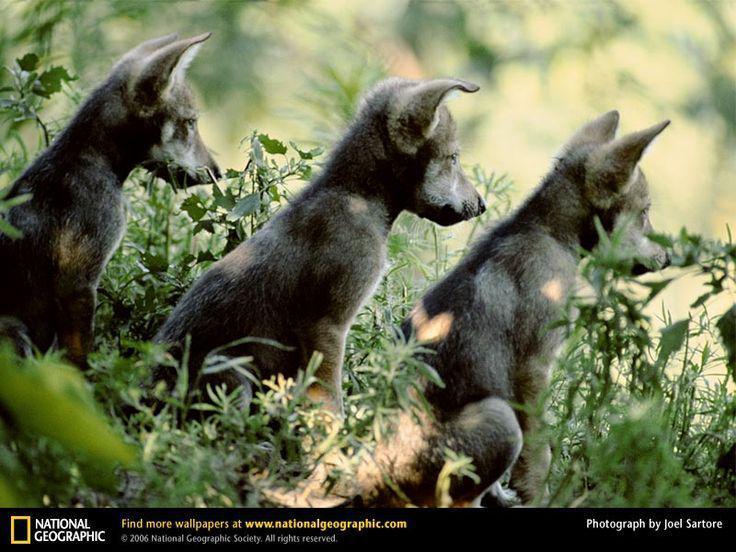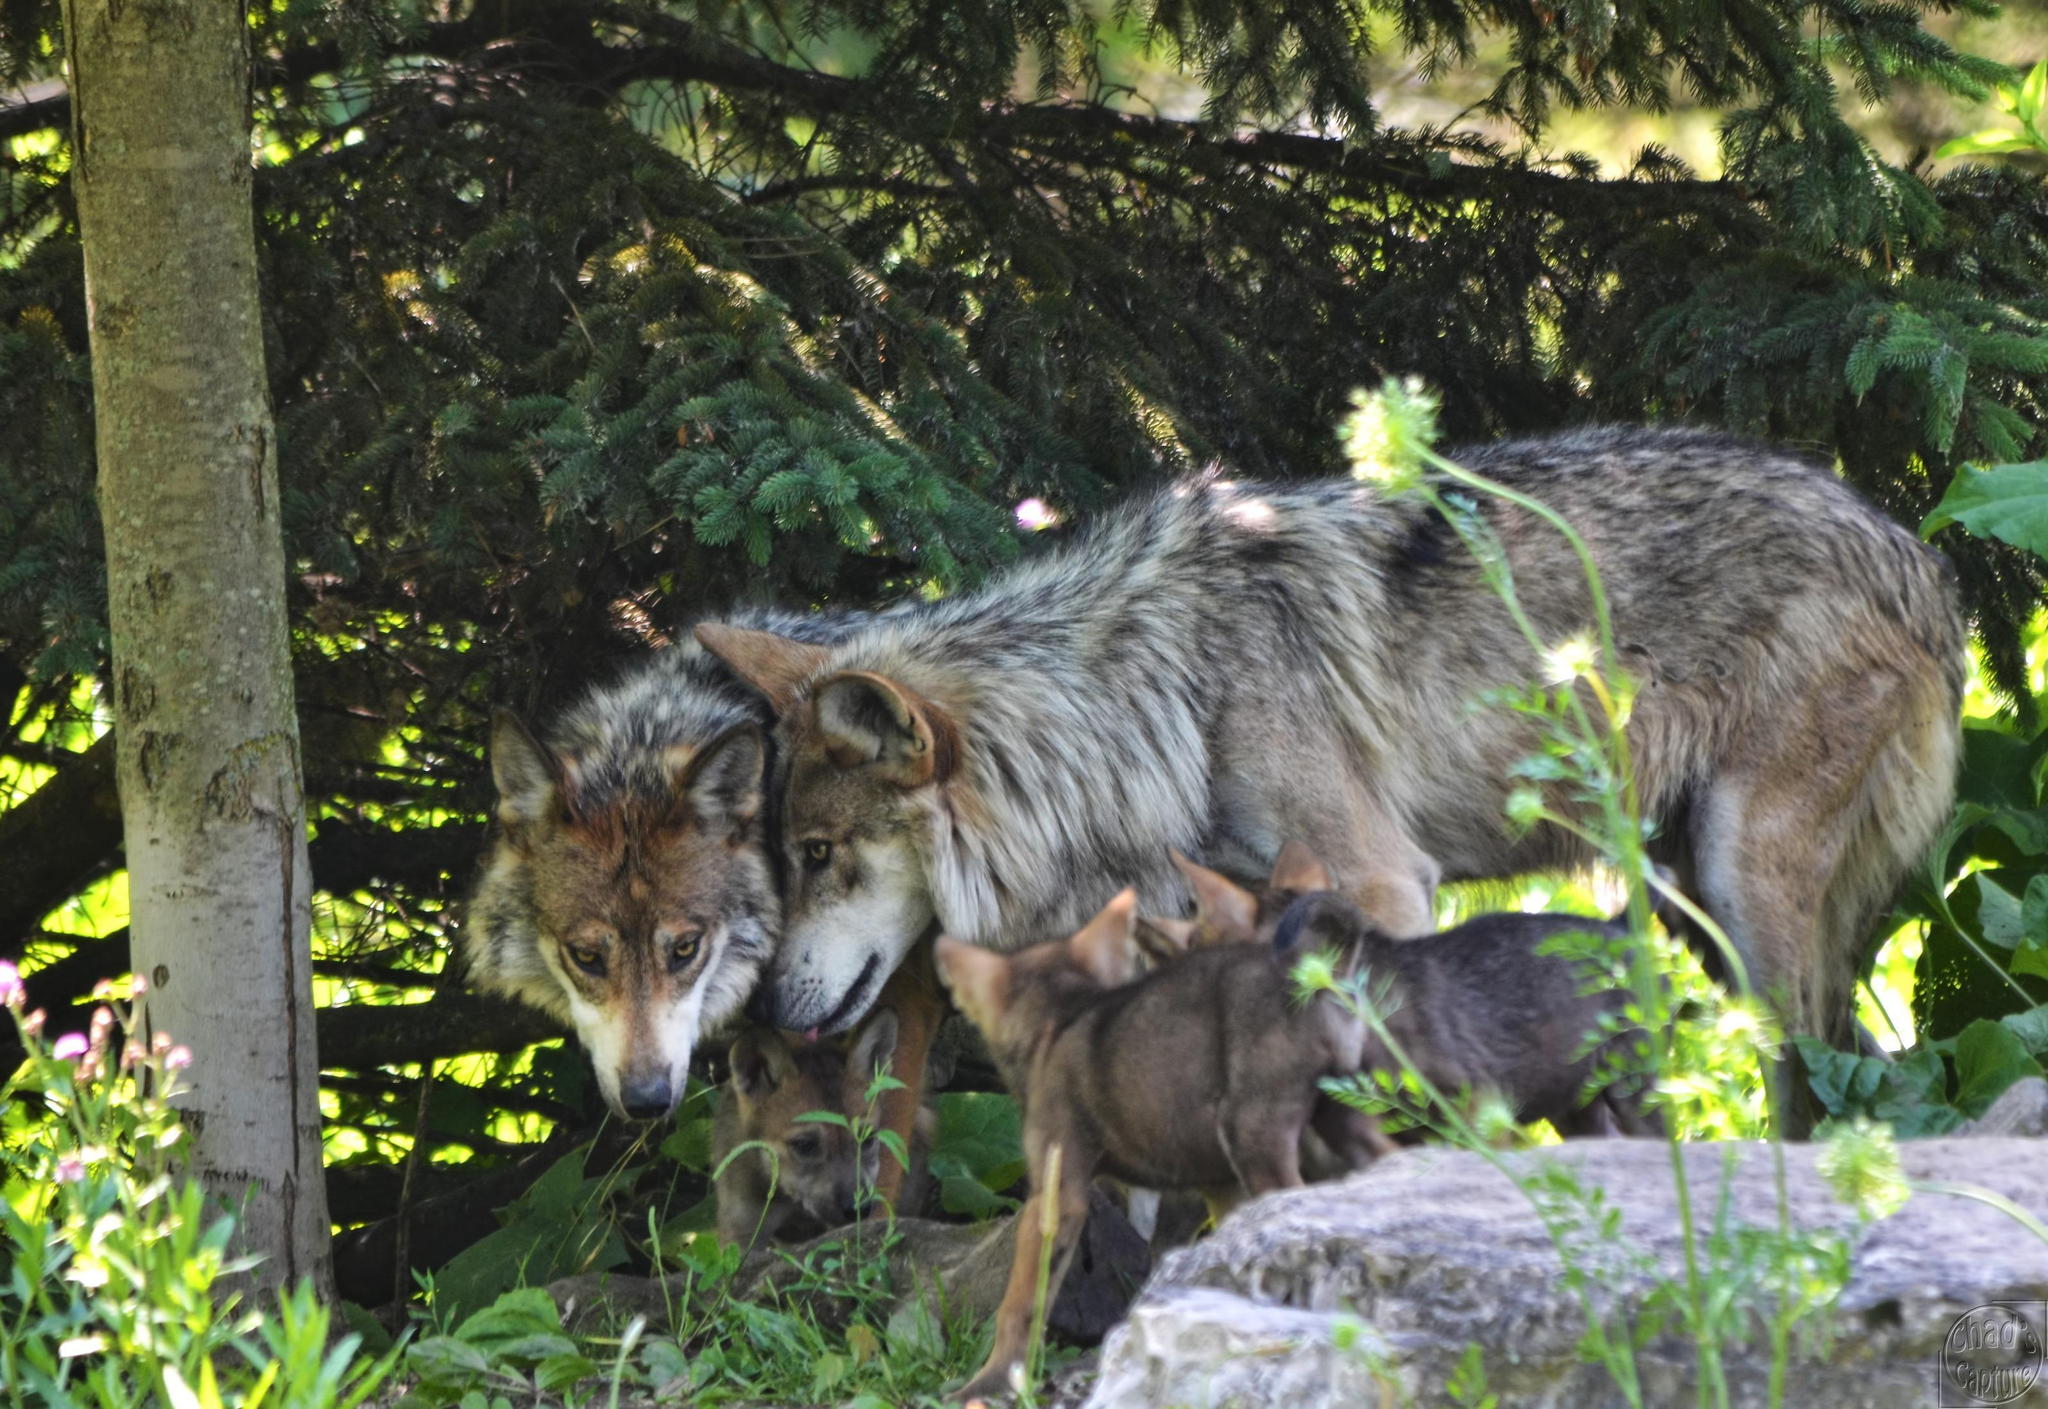The first image is the image on the left, the second image is the image on the right. Examine the images to the left and right. Is the description "There is one dog outside in the image on the right." accurate? Answer yes or no. No. 